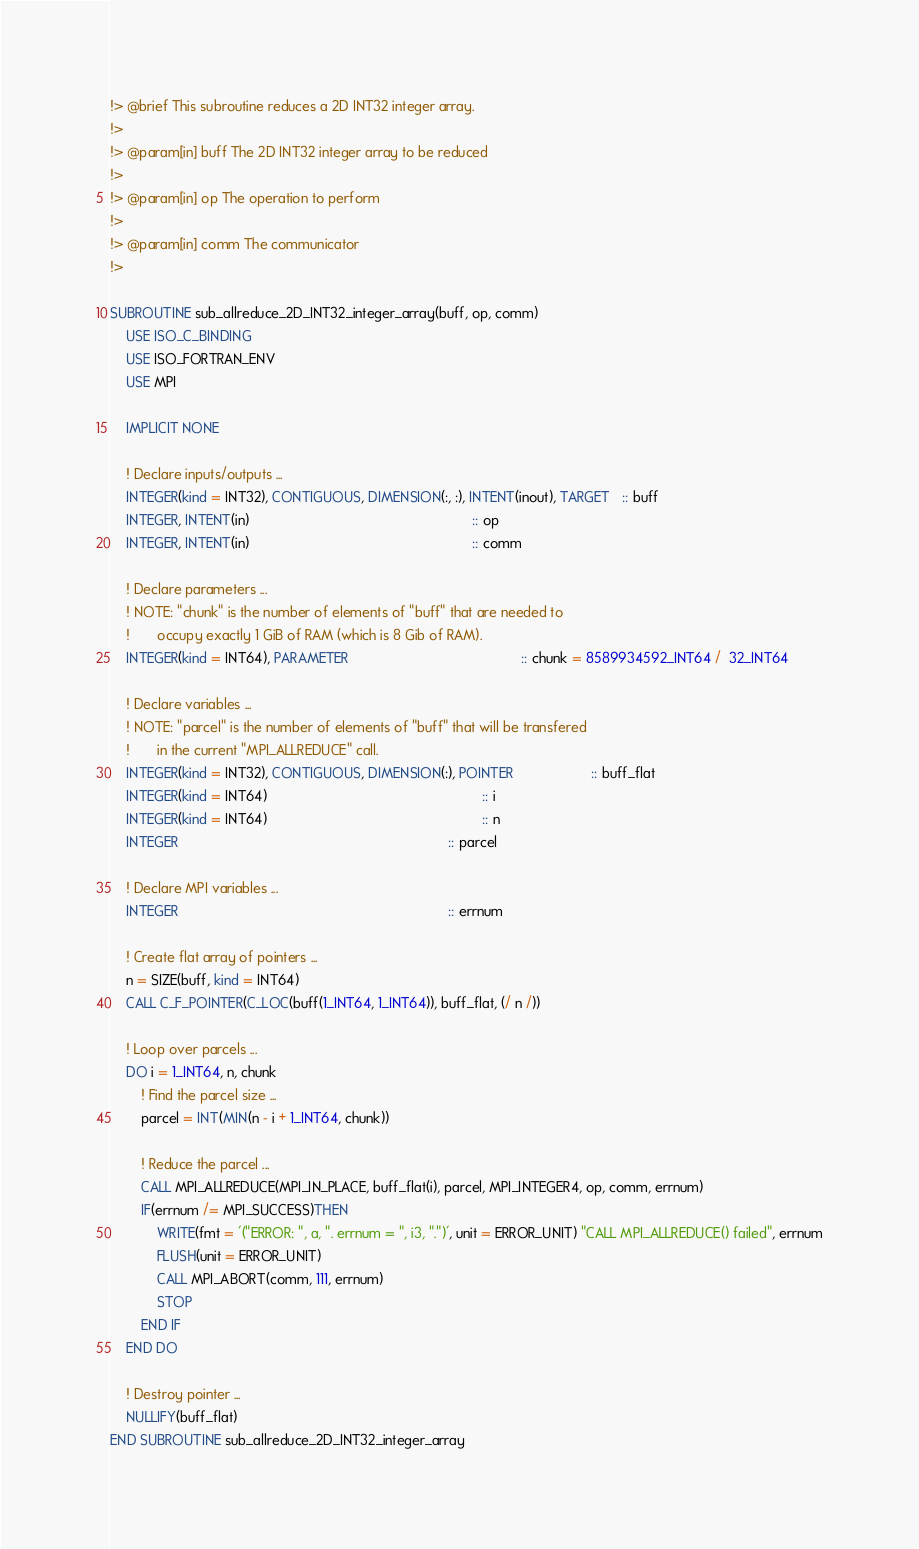Convert code to text. <code><loc_0><loc_0><loc_500><loc_500><_FORTRAN_>!> @brief This subroutine reduces a 2D INT32 integer array.
!>
!> @param[in] buff The 2D INT32 integer array to be reduced
!>
!> @param[in] op The operation to perform
!>
!> @param[in] comm The communicator
!>

SUBROUTINE sub_allreduce_2D_INT32_integer_array(buff, op, comm)
    USE ISO_C_BINDING
    USE ISO_FORTRAN_ENV
    USE MPI

    IMPLICIT NONE

    ! Declare inputs/outputs ...
    INTEGER(kind = INT32), CONTIGUOUS, DIMENSION(:, :), INTENT(inout), TARGET   :: buff
    INTEGER, INTENT(in)                                                         :: op
    INTEGER, INTENT(in)                                                         :: comm

    ! Declare parameters ...
    ! NOTE: "chunk" is the number of elements of "buff" that are needed to
    !       occupy exactly 1 GiB of RAM (which is 8 Gib of RAM).
    INTEGER(kind = INT64), PARAMETER                                            :: chunk = 8589934592_INT64 /  32_INT64

    ! Declare variables ...
    ! NOTE: "parcel" is the number of elements of "buff" that will be transfered
    !       in the current "MPI_ALLREDUCE" call.
    INTEGER(kind = INT32), CONTIGUOUS, DIMENSION(:), POINTER                    :: buff_flat
    INTEGER(kind = INT64)                                                       :: i
    INTEGER(kind = INT64)                                                       :: n
    INTEGER                                                                     :: parcel

    ! Declare MPI variables ...
    INTEGER                                                                     :: errnum

    ! Create flat array of pointers ...
    n = SIZE(buff, kind = INT64)
    CALL C_F_POINTER(C_LOC(buff(1_INT64, 1_INT64)), buff_flat, (/ n /))

    ! Loop over parcels ...
    DO i = 1_INT64, n, chunk
        ! Find the parcel size ...
        parcel = INT(MIN(n - i + 1_INT64, chunk))

        ! Reduce the parcel ...
        CALL MPI_ALLREDUCE(MPI_IN_PLACE, buff_flat(i), parcel, MPI_INTEGER4, op, comm, errnum)
        IF(errnum /= MPI_SUCCESS)THEN
            WRITE(fmt = '("ERROR: ", a, ". errnum = ", i3, ".")', unit = ERROR_UNIT) "CALL MPI_ALLREDUCE() failed", errnum
            FLUSH(unit = ERROR_UNIT)
            CALL MPI_ABORT(comm, 111, errnum)
            STOP
        END IF
    END DO

    ! Destroy pointer ...
    NULLIFY(buff_flat)
END SUBROUTINE sub_allreduce_2D_INT32_integer_array
</code> 